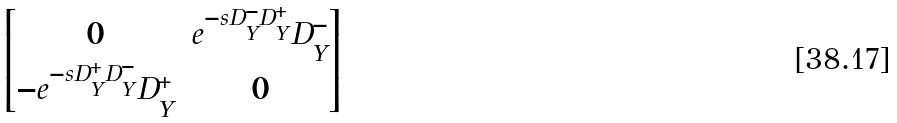<formula> <loc_0><loc_0><loc_500><loc_500>\begin{bmatrix} 0 & e ^ { - s D _ { Y } ^ { - } D _ { Y } ^ { + } } D ^ { - } _ { Y } \\ - e ^ { - s D _ { Y } ^ { + } D _ { Y } ^ { - } } D _ { Y } ^ { + } & 0 \end{bmatrix}</formula> 